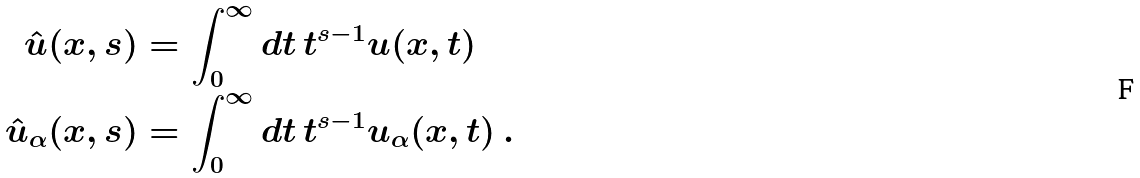Convert formula to latex. <formula><loc_0><loc_0><loc_500><loc_500>\hat { u } ( x , s ) & = \int _ { 0 } ^ { \infty } d t \, t ^ { s - 1 } u ( x , t ) \\ \hat { u } _ { \alpha } ( x , s ) & = \int _ { 0 } ^ { \infty } d t \, t ^ { s - 1 } u _ { \alpha } ( x , t ) \, .</formula> 